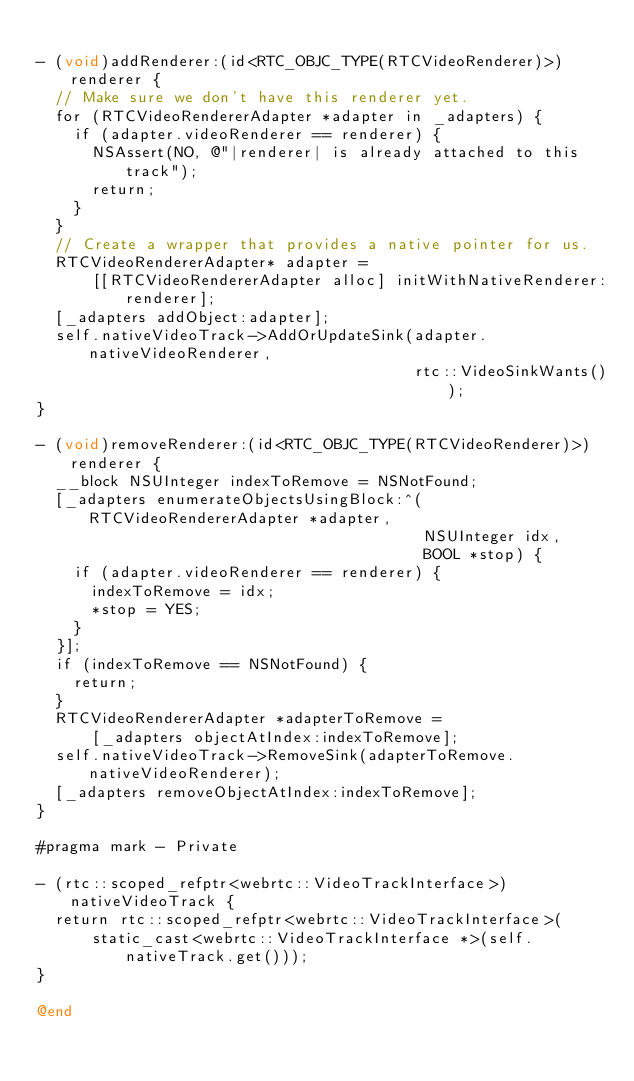<code> <loc_0><loc_0><loc_500><loc_500><_ObjectiveC_>
- (void)addRenderer:(id<RTC_OBJC_TYPE(RTCVideoRenderer)>)renderer {
  // Make sure we don't have this renderer yet.
  for (RTCVideoRendererAdapter *adapter in _adapters) {
    if (adapter.videoRenderer == renderer) {
      NSAssert(NO, @"|renderer| is already attached to this track");
      return;
    }
  }
  // Create a wrapper that provides a native pointer for us.
  RTCVideoRendererAdapter* adapter =
      [[RTCVideoRendererAdapter alloc] initWithNativeRenderer:renderer];
  [_adapters addObject:adapter];
  self.nativeVideoTrack->AddOrUpdateSink(adapter.nativeVideoRenderer,
                                         rtc::VideoSinkWants());
}

- (void)removeRenderer:(id<RTC_OBJC_TYPE(RTCVideoRenderer)>)renderer {
  __block NSUInteger indexToRemove = NSNotFound;
  [_adapters enumerateObjectsUsingBlock:^(RTCVideoRendererAdapter *adapter,
                                          NSUInteger idx,
                                          BOOL *stop) {
    if (adapter.videoRenderer == renderer) {
      indexToRemove = idx;
      *stop = YES;
    }
  }];
  if (indexToRemove == NSNotFound) {
    return;
  }
  RTCVideoRendererAdapter *adapterToRemove =
      [_adapters objectAtIndex:indexToRemove];
  self.nativeVideoTrack->RemoveSink(adapterToRemove.nativeVideoRenderer);
  [_adapters removeObjectAtIndex:indexToRemove];
}

#pragma mark - Private

- (rtc::scoped_refptr<webrtc::VideoTrackInterface>)nativeVideoTrack {
  return rtc::scoped_refptr<webrtc::VideoTrackInterface>(
      static_cast<webrtc::VideoTrackInterface *>(self.nativeTrack.get()));
}

@end
</code> 